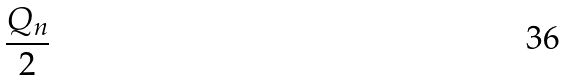Convert formula to latex. <formula><loc_0><loc_0><loc_500><loc_500>\frac { Q _ { n } } { 2 }</formula> 